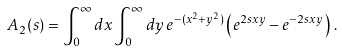Convert formula to latex. <formula><loc_0><loc_0><loc_500><loc_500>A _ { 2 } ( s ) & = \int ^ { \infty } _ { 0 } d x \int ^ { \infty } _ { 0 } d y \, e ^ { - ( x ^ { 2 } + y ^ { 2 } ) } \left ( e ^ { 2 s x y } - e ^ { - 2 s x y } \right ) \, .</formula> 